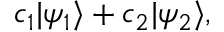<formula> <loc_0><loc_0><loc_500><loc_500>c _ { 1 } | \psi _ { 1 } \rangle + c _ { 2 } | \psi _ { 2 } \rangle ,</formula> 